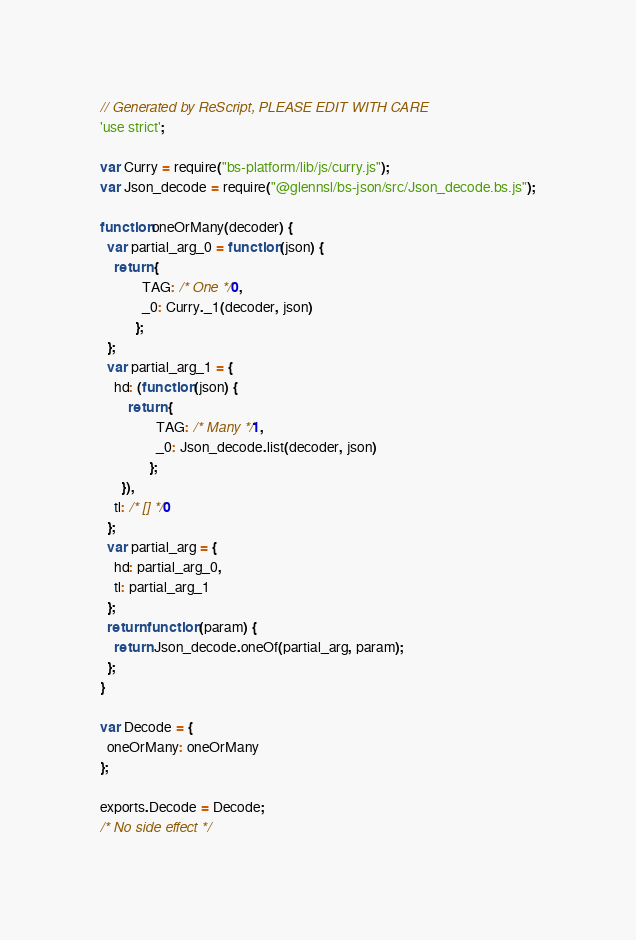<code> <loc_0><loc_0><loc_500><loc_500><_JavaScript_>// Generated by ReScript, PLEASE EDIT WITH CARE
'use strict';

var Curry = require("bs-platform/lib/js/curry.js");
var Json_decode = require("@glennsl/bs-json/src/Json_decode.bs.js");

function oneOrMany(decoder) {
  var partial_arg_0 = function (json) {
    return {
            TAG: /* One */0,
            _0: Curry._1(decoder, json)
          };
  };
  var partial_arg_1 = {
    hd: (function (json) {
        return {
                TAG: /* Many */1,
                _0: Json_decode.list(decoder, json)
              };
      }),
    tl: /* [] */0
  };
  var partial_arg = {
    hd: partial_arg_0,
    tl: partial_arg_1
  };
  return function (param) {
    return Json_decode.oneOf(partial_arg, param);
  };
}

var Decode = {
  oneOrMany: oneOrMany
};

exports.Decode = Decode;
/* No side effect */
</code> 